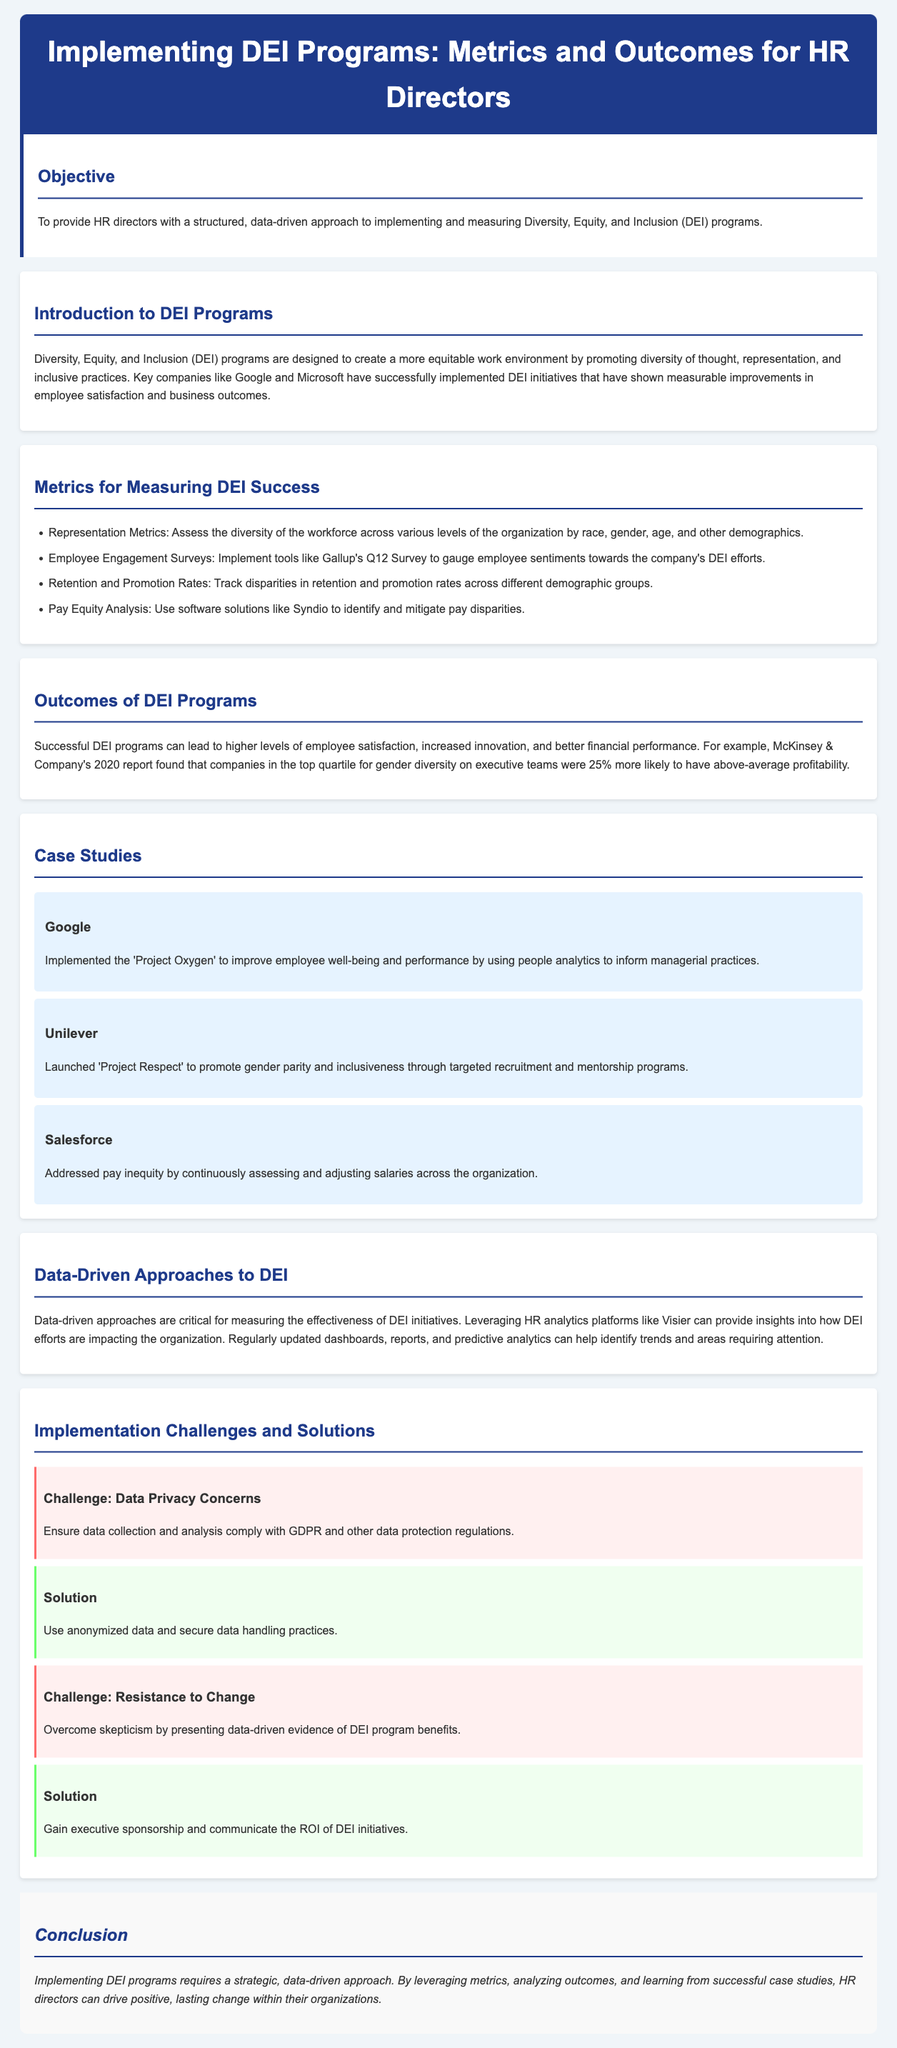What is the title of the lesson plan? The title of the lesson plan is presented in the header section of the document.
Answer: Implementing DEI Programs: Metrics and Outcomes for HR Directors What are the objectives of the lesson plan? The objective is stated in the introduction section of the document.
Answer: To provide HR directors with a structured, data-driven approach to implementing and measuring Diversity, Equity, and Inclusion (DEI) programs Which company implemented 'Project Oxygen'? 'Project Oxygen' is mentioned in the case studies section, specifying the company that implemented it.
Answer: Google What metric is used to assess employee sentiments towards DEI efforts? This metric is outlined in the Metrics for Measuring DEI Success section of the document.
Answer: Employee Engagement Surveys What percentage more likely are companies with gender-diverse executive teams to have above-average profitability? This statistic is provided in the Outcomes of DEI Programs section.
Answer: 25% What is a challenge related to implementing DEI programs? The lesson plan lists challenges in the Implementation Challenges and Solutions section.
Answer: Data Privacy Concerns What is a solution proposed for overcoming resistance to change? The proposed solution is mentioned in conjunction with the challenge of resistance to change.
Answer: Gain executive sponsorship and communicate the ROI of DEI initiatives Which company's initiative promotes gender parity through targeted recruitment? This initiative is detailed in the case studies section.
Answer: Unilever 